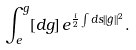Convert formula to latex. <formula><loc_0><loc_0><loc_500><loc_500>\int _ { e } ^ { g } [ d g ] \, e ^ { \frac { i } { 2 } \int d s | | \dot { g } | | ^ { 2 } } .</formula> 